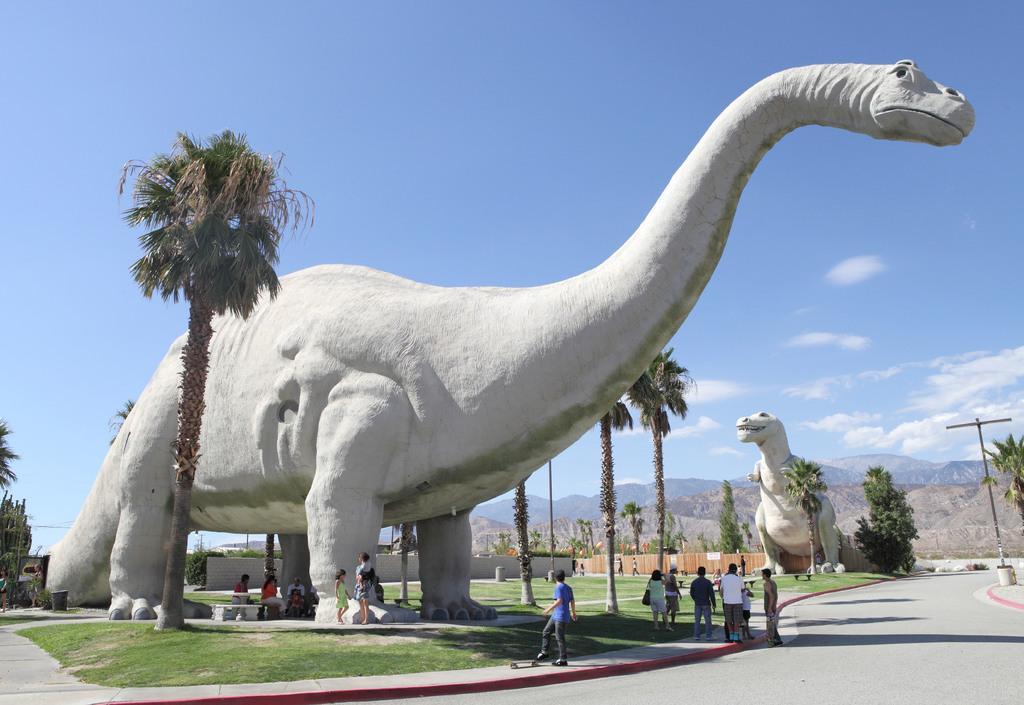In one or two sentences, can you explain what this image depicts? In this image there is a large dragon statue in the middle. At the bottom there are few people who are standing and watching it. There are trees in the background. At the top there is the sky. On the left side there is a ground. On the right side there is a road. Beside the road there is a pole. In the background there is another statue. 